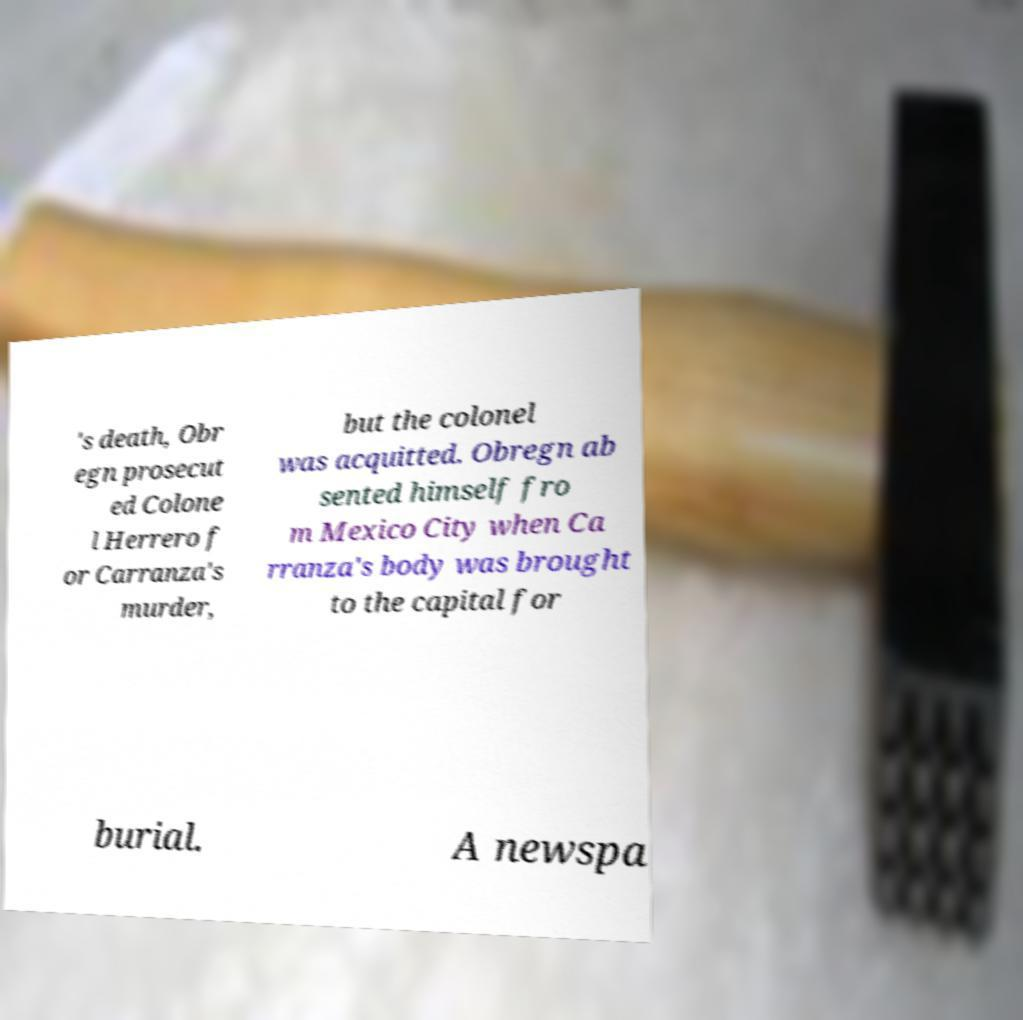What messages or text are displayed in this image? I need them in a readable, typed format. 's death, Obr egn prosecut ed Colone l Herrero f or Carranza's murder, but the colonel was acquitted. Obregn ab sented himself fro m Mexico City when Ca rranza's body was brought to the capital for burial. A newspa 